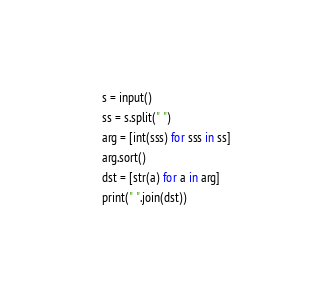Convert code to text. <code><loc_0><loc_0><loc_500><loc_500><_Python_>s = input()
ss = s.split(" ")
arg = [int(sss) for sss in ss]
arg.sort()
dst = [str(a) for a in arg]
print(" ".join(dst))
</code> 